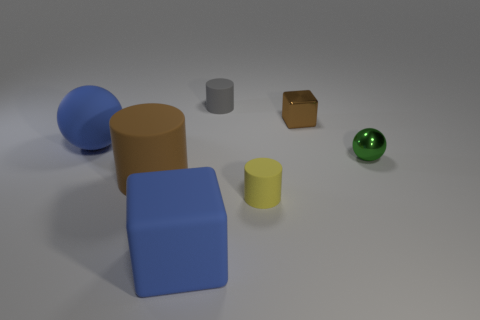Subtract all big brown cylinders. How many cylinders are left? 2 Subtract all brown cubes. How many cubes are left? 1 Add 3 large blue objects. How many objects exist? 10 Subtract 1 spheres. How many spheres are left? 1 Subtract all balls. How many objects are left? 5 Subtract all blue cubes. Subtract all green balls. How many cubes are left? 1 Subtract all large metallic blocks. Subtract all green balls. How many objects are left? 6 Add 6 gray cylinders. How many gray cylinders are left? 7 Add 7 brown metallic blocks. How many brown metallic blocks exist? 8 Subtract 1 brown cubes. How many objects are left? 6 